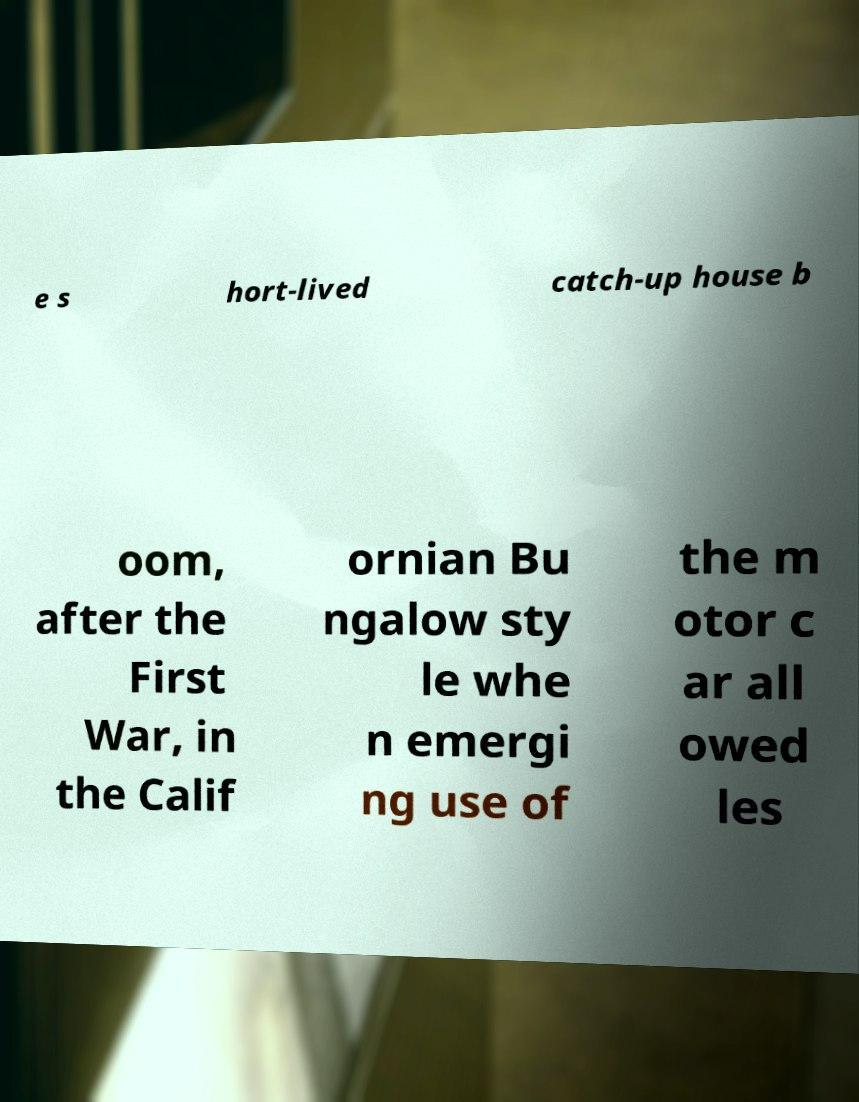What messages or text are displayed in this image? I need them in a readable, typed format. e s hort-lived catch-up house b oom, after the First War, in the Calif ornian Bu ngalow sty le whe n emergi ng use of the m otor c ar all owed les 